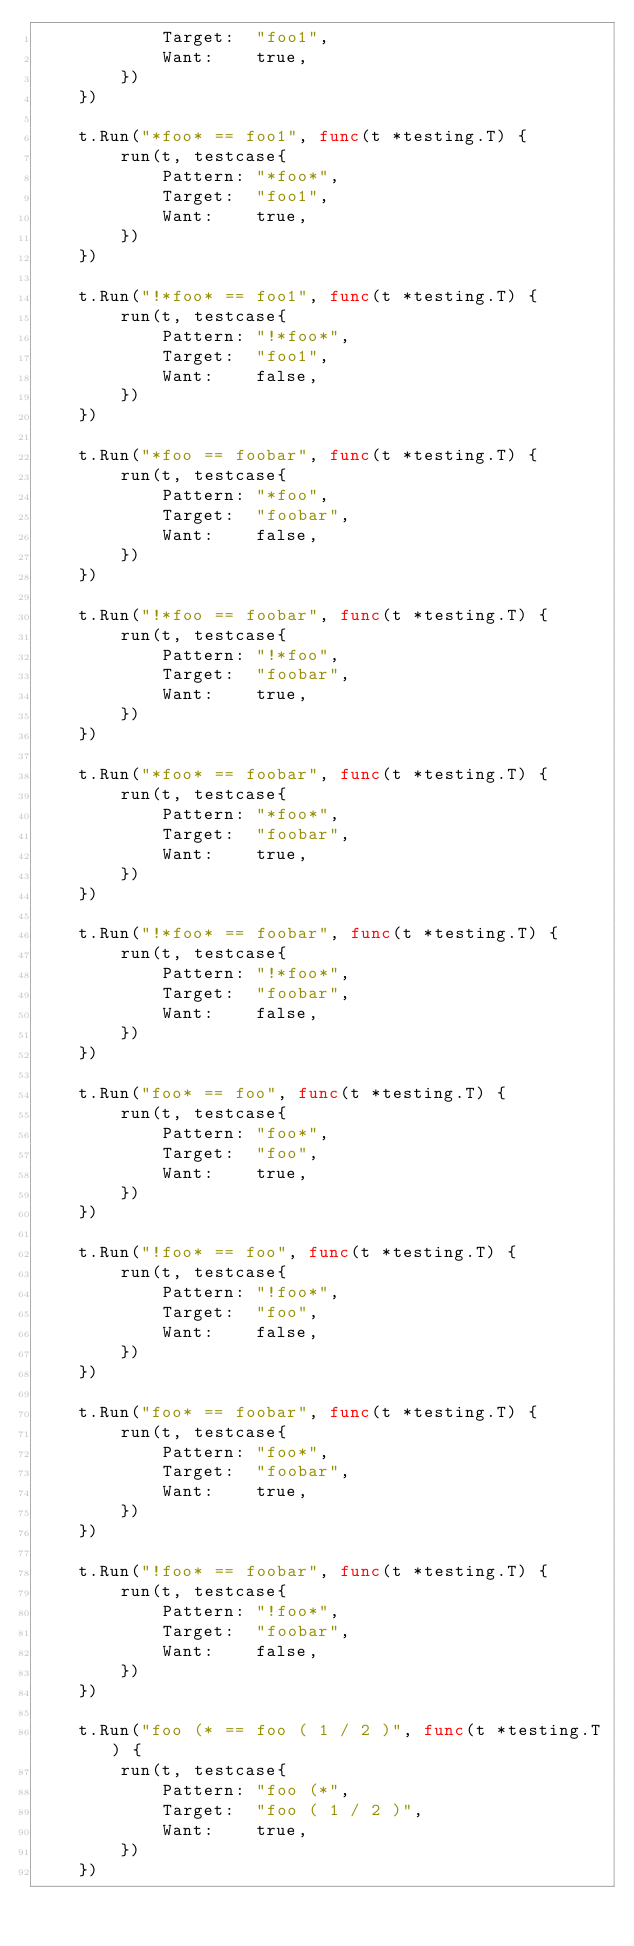<code> <loc_0><loc_0><loc_500><loc_500><_Go_>			Target:  "foo1",
			Want:    true,
		})
	})

	t.Run("*foo* == foo1", func(t *testing.T) {
		run(t, testcase{
			Pattern: "*foo*",
			Target:  "foo1",
			Want:    true,
		})
	})

	t.Run("!*foo* == foo1", func(t *testing.T) {
		run(t, testcase{
			Pattern: "!*foo*",
			Target:  "foo1",
			Want:    false,
		})
	})

	t.Run("*foo == foobar", func(t *testing.T) {
		run(t, testcase{
			Pattern: "*foo",
			Target:  "foobar",
			Want:    false,
		})
	})

	t.Run("!*foo == foobar", func(t *testing.T) {
		run(t, testcase{
			Pattern: "!*foo",
			Target:  "foobar",
			Want:    true,
		})
	})

	t.Run("*foo* == foobar", func(t *testing.T) {
		run(t, testcase{
			Pattern: "*foo*",
			Target:  "foobar",
			Want:    true,
		})
	})

	t.Run("!*foo* == foobar", func(t *testing.T) {
		run(t, testcase{
			Pattern: "!*foo*",
			Target:  "foobar",
			Want:    false,
		})
	})

	t.Run("foo* == foo", func(t *testing.T) {
		run(t, testcase{
			Pattern: "foo*",
			Target:  "foo",
			Want:    true,
		})
	})

	t.Run("!foo* == foo", func(t *testing.T) {
		run(t, testcase{
			Pattern: "!foo*",
			Target:  "foo",
			Want:    false,
		})
	})

	t.Run("foo* == foobar", func(t *testing.T) {
		run(t, testcase{
			Pattern: "foo*",
			Target:  "foobar",
			Want:    true,
		})
	})

	t.Run("!foo* == foobar", func(t *testing.T) {
		run(t, testcase{
			Pattern: "!foo*",
			Target:  "foobar",
			Want:    false,
		})
	})

	t.Run("foo (* == foo ( 1 / 2 )", func(t *testing.T) {
		run(t, testcase{
			Pattern: "foo (*",
			Target:  "foo ( 1 / 2 )",
			Want:    true,
		})
	})
</code> 